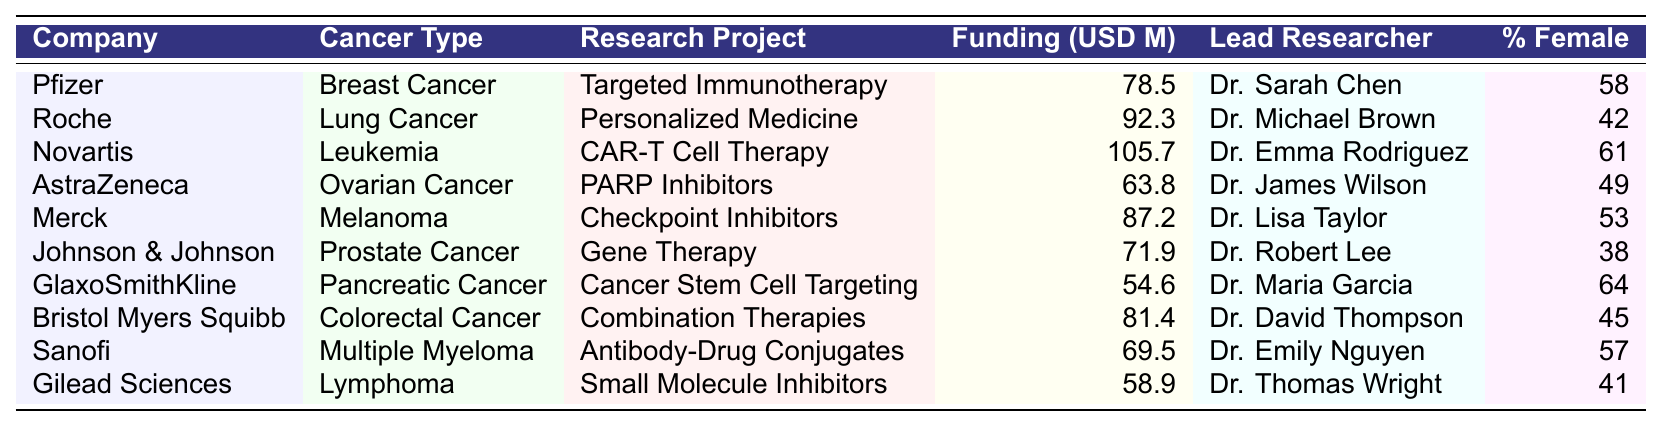What is the annual funding allocated to Novartis for its leukemia research project? The table directly lists the annual funding for Novartis's CAR-T Cell Therapy project under leukemia, which is provided as 105.7 million USD.
Answer: 105.7 million USD Which cancer type has the highest funding allocation? By comparing the funding allocations listed in the table, Novartis for leukemia has the highest annual funding of 105.7 million USD.
Answer: Leukemia How many projects have a funding amount greater than 80 million USD? Reviewing the funding amounts, the projects with amounts greater than 80 million USD are: Novartis (105.7), Roche (92.3), Merck (87.2), and Bristol Myers Squibb (81.4) – totaling four projects.
Answer: 4 What is the percentage of female researchers in AstraZeneca's ovarian cancer research project? The table indicates that AstraZeneca has a project in ovarian cancer led by Dr. James Wilson, with 49% female researchers listed.
Answer: 49% Which pharmaceutical company has the highest percentage of female researchers, and what is that percentage? GlaxoSmithKline has the highest percentage of female researchers at 64%, as noted in the table for their pancreatic cancer project led by Dr. Maria Garcia.
Answer: 64% Is the lead researcher for Merck's melanoma project female? The table shows that the lead researcher for Merck's project, Dr. Lisa Taylor, is female, which confirms that she is indeed female.
Answer: Yes What is the average annual funding allocated to the projects with at least 50% female researchers? The projects with at least 50% female researchers are Pfizer (78.5), Novartis (105.7), Merck (87.2), GlaxoSmithKline (54.6), Sanofi (69.5). The average is calculated by summing these values (78.5 + 105.7 + 87.2 + 54.6 + 69.5 = 395.5) and dividing by the total projects (5). Therefore, the average is 395.5 / 5 = 79.1 million USD.
Answer: 79.1 million USD Which cancer type has the lowest funding allocation? Reviewing the funding amounts, Gilead Sciences for lymphoma has the lowest funding allocation of 58.9 million USD, as listed in the table.
Answer: Lymphoma How many funding allocations are greater than 70 million USD but less than 80 million USD? By examining the funding allocations in the table, the rows for Pfizer (78.5) and Johnson & Johnson (71.9) fit this criteria; thus, there are two allocations in this range.
Answer: 2 What is the total funding allocated to all projects related to female cancers (breast, ovarian)? Summing the allocations for Pfizer (78.5) for breast cancer and AstraZeneca (63.8) for ovarian cancer gives a total of (78.5 + 63.8 = 142.3) million USD for these projects combined.
Answer: 142.3 million USD 